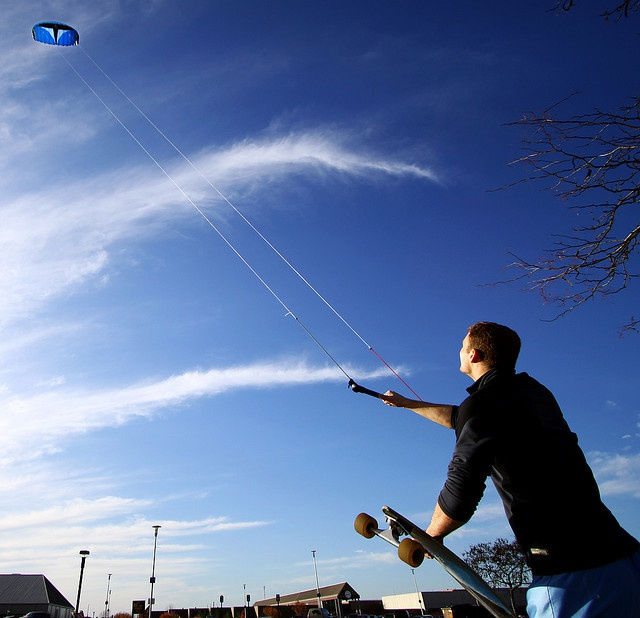Describe the objects in this image and their specific colors. I can see people in gray, black, and blue tones, skateboard in gray, black, maroon, and darkblue tones, kite in gray, blue, black, darkblue, and navy tones, and car in gray, black, and darkgray tones in this image. 